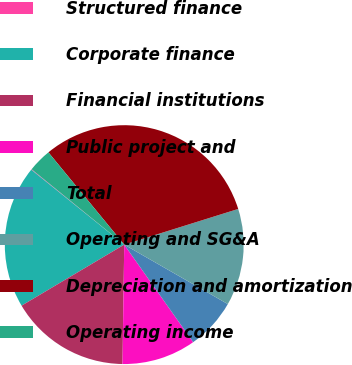<chart> <loc_0><loc_0><loc_500><loc_500><pie_chart><fcel>Structured finance<fcel>Corporate finance<fcel>Financial institutions<fcel>Public project and<fcel>Total<fcel>Operating and SG&A<fcel>Depreciation and amortization<fcel>Operating income<nl><fcel>0.08%<fcel>19.33%<fcel>16.23%<fcel>10.02%<fcel>6.92%<fcel>13.12%<fcel>31.12%<fcel>3.18%<nl></chart> 